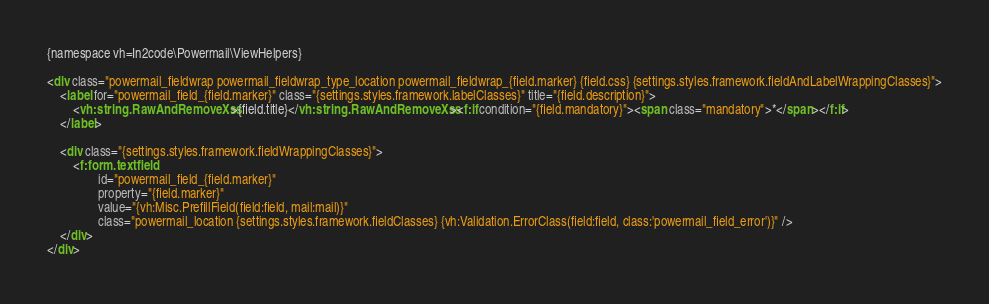<code> <loc_0><loc_0><loc_500><loc_500><_HTML_>{namespace vh=In2code\Powermail\ViewHelpers}

<div class="powermail_fieldwrap powermail_fieldwrap_type_location powermail_fieldwrap_{field.marker} {field.css} {settings.styles.framework.fieldAndLabelWrappingClasses}">
	<label for="powermail_field_{field.marker}" class="{settings.styles.framework.labelClasses}" title="{field.description}">
		<vh:string.RawAndRemoveXss>{field.title}</vh:string.RawAndRemoveXss><f:if condition="{field.mandatory}"><span class="mandatory">*</span></f:if>
	</label>

	<div class="{settings.styles.framework.fieldWrappingClasses}">
		<f:form.textfield
				id="powermail_field_{field.marker}"
				property="{field.marker}"
				value="{vh:Misc.PrefillField(field:field, mail:mail)}"
				class="powermail_location {settings.styles.framework.fieldClasses} {vh:Validation.ErrorClass(field:field, class:'powermail_field_error')}" />
	</div>
</div>
</code> 